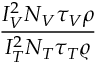Convert formula to latex. <formula><loc_0><loc_0><loc_500><loc_500>\frac { I _ { V } ^ { 2 } N _ { V } \tau _ { V } \rho } { I _ { T } ^ { 2 } N _ { T } \tau _ { T } \varrho }</formula> 